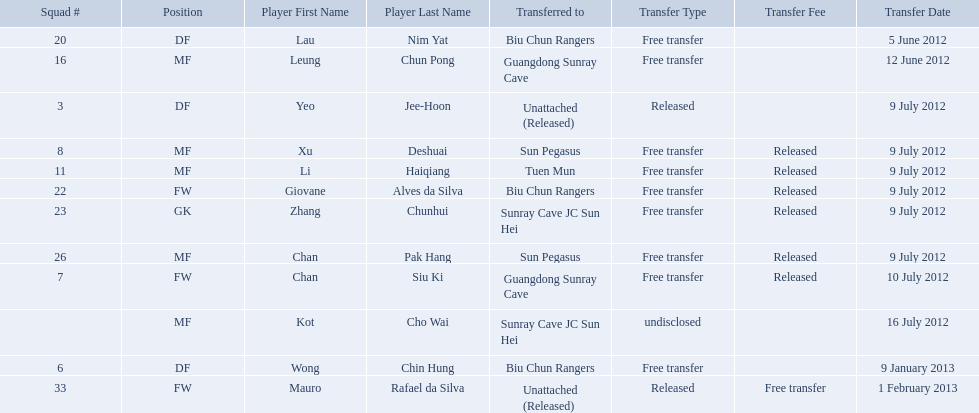On what dates were there non released free transfers? 5 June 2012, 12 June 2012, 9 January 2013, 1 February 2013. On which of these were the players transferred to another team? 5 June 2012, 12 June 2012, 9 January 2013. Which of these were the transfers to biu chun rangers? 5 June 2012, 9 January 2013. On which of those dated did they receive a df? 9 January 2013. Which players are listed? Lau Nim Yat, Leung Chun Pong, Yeo Jee-Hoon, Xu Deshuai, Li Haiqiang, Giovane Alves da Silva, Zhang Chunhui, Chan Pak Hang, Chan Siu Ki, Kot Cho Wai, Wong Chin Hung, Mauro Rafael da Silva. Which dates were players transferred to the biu chun rangers? 5 June 2012, 9 July 2012, 9 January 2013. Of those which is the date for wong chin hung? 9 January 2013. 